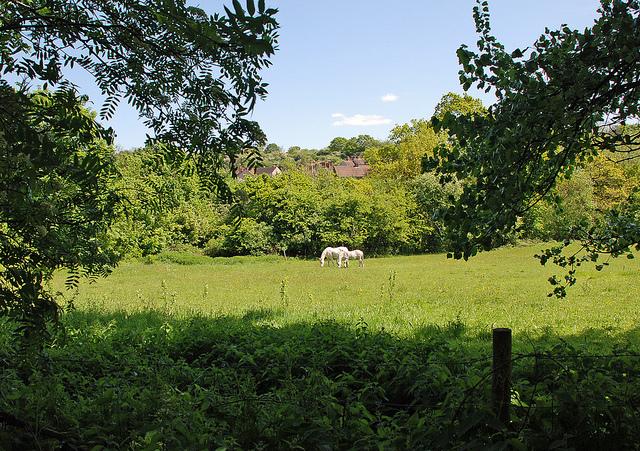Are the houses almost covered by trees?
Keep it brief. Yes. Are these horses tame?
Short answer required. Yes. Where could a person sit and rest?
Quick response, please. Grass. What structure is in the background?
Concise answer only. House. Is there a road in the forest?
Concise answer only. No. Is there a clock?
Answer briefly. No. Do you see an animal in the photo?
Quick response, please. Yes. What is there to sit on in the field?
Write a very short answer. Grass. What kind of animal is this?
Answer briefly. Horse. Is there a street in the scene?
Give a very brief answer. No. Is this a city block?
Answer briefly. No. Is there something about these animals reminiscent of the psychedelic flavor of the sixties?
Short answer required. No. How many benches are here?
Quick response, please. 0. 